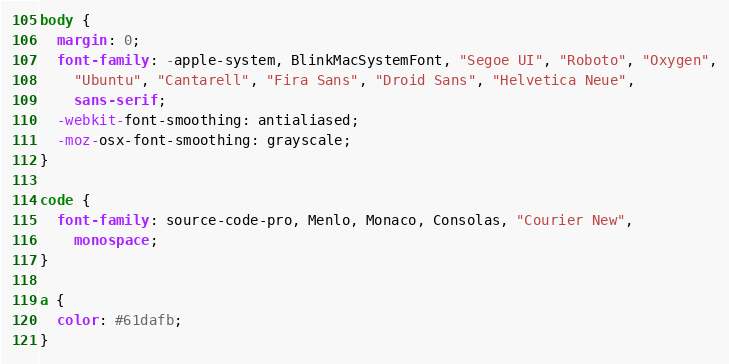<code> <loc_0><loc_0><loc_500><loc_500><_CSS_>body {
  margin: 0;
  font-family: -apple-system, BlinkMacSystemFont, "Segoe UI", "Roboto", "Oxygen",
    "Ubuntu", "Cantarell", "Fira Sans", "Droid Sans", "Helvetica Neue",
    sans-serif;
  -webkit-font-smoothing: antialiased;
  -moz-osx-font-smoothing: grayscale;
}

code {
  font-family: source-code-pro, Menlo, Monaco, Consolas, "Courier New",
    monospace;
}

a {
  color: #61dafb;
}
</code> 